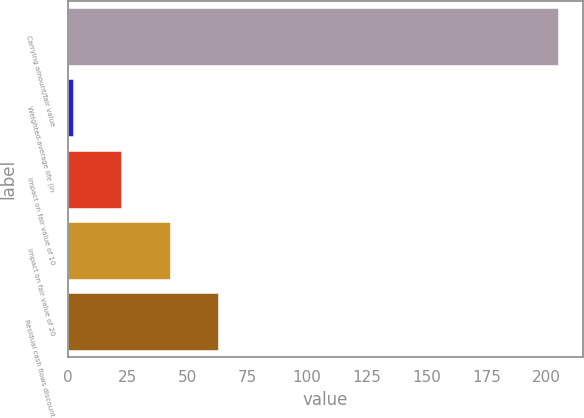<chart> <loc_0><loc_0><loc_500><loc_500><bar_chart><fcel>Carrying amount/fair value<fcel>Weighted-average life (in<fcel>Impact on fair value of 10<fcel>Impact on fair value of 20<fcel>Residual cash flows discount<nl><fcel>205<fcel>1.87<fcel>22.18<fcel>42.49<fcel>62.8<nl></chart> 